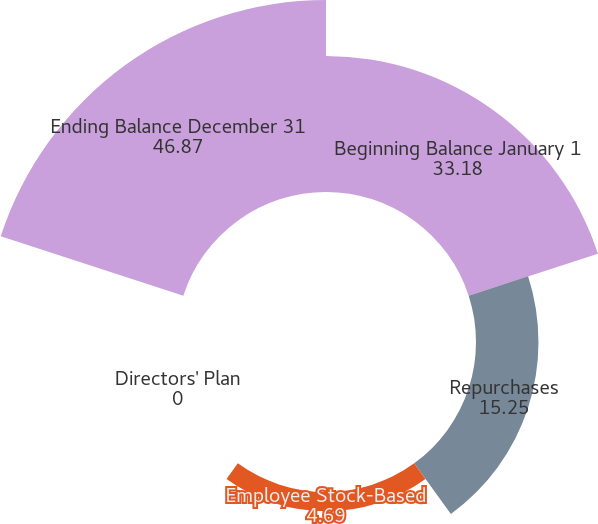Convert chart to OTSL. <chart><loc_0><loc_0><loc_500><loc_500><pie_chart><fcel>Beginning Balance January 1<fcel>Repurchases<fcel>Employee Stock-Based<fcel>Directors' Plan<fcel>Ending Balance December 31<nl><fcel>33.18%<fcel>15.25%<fcel>4.69%<fcel>0.0%<fcel>46.87%<nl></chart> 